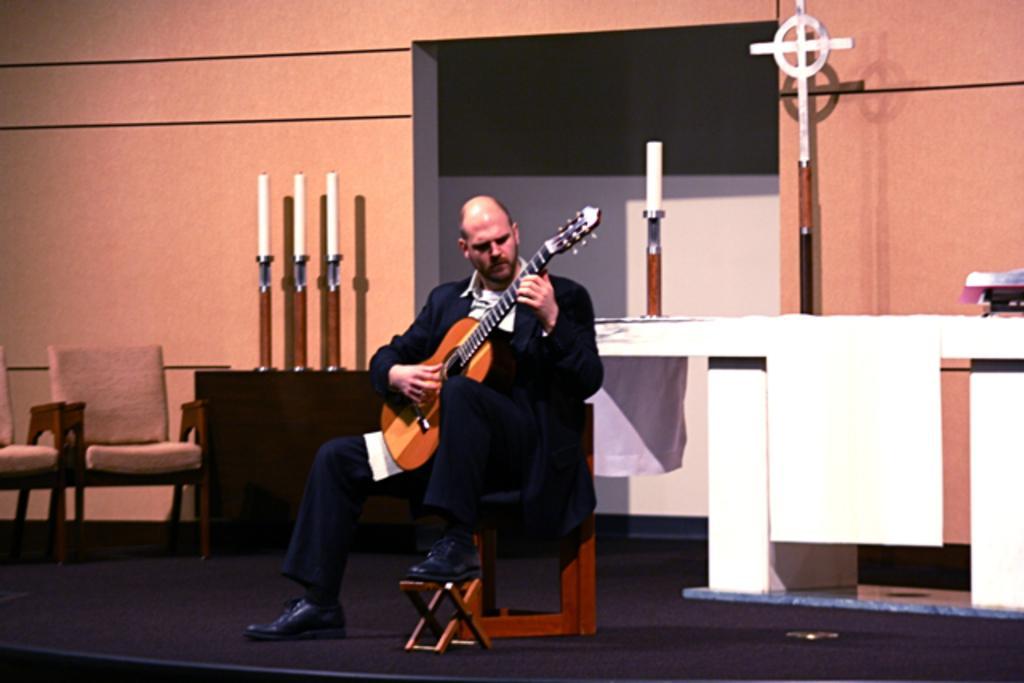Describe this image in one or two sentences. A person is playing guitar behind him there are chairs,a wall and a candle with stand. 